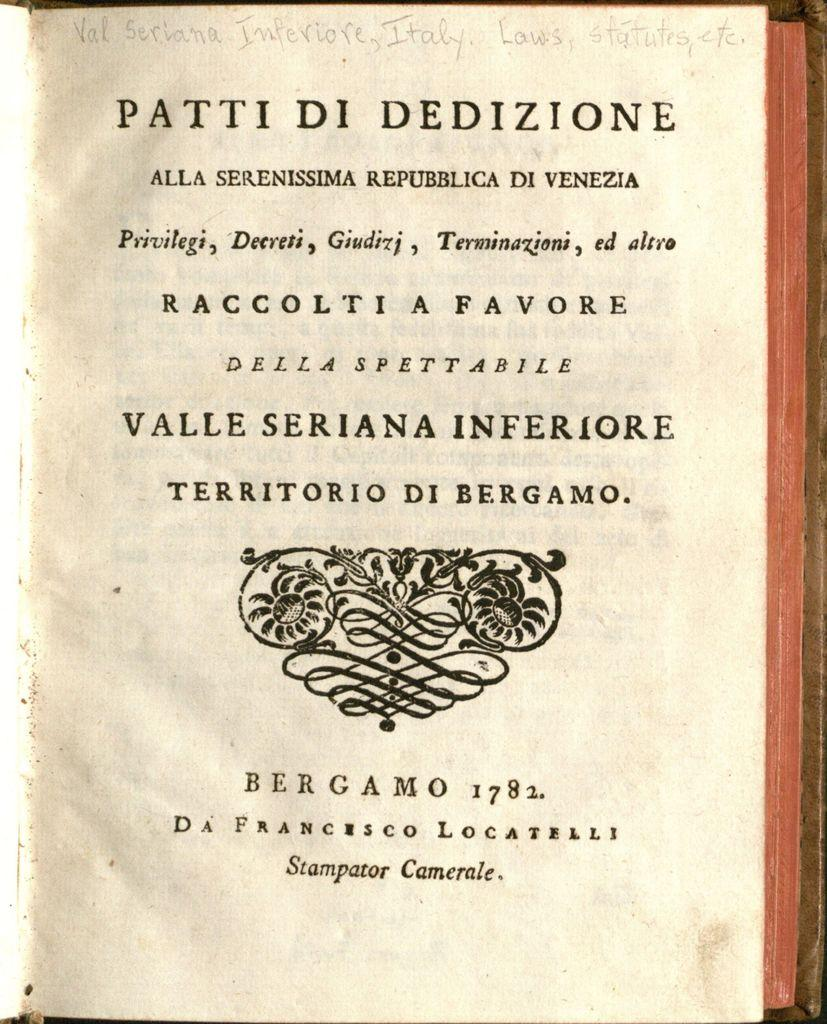<image>
Create a compact narrative representing the image presented. The cover of a book bearing many Italian words has been marked by a pencil indicating that the book is about laws and statutes. 